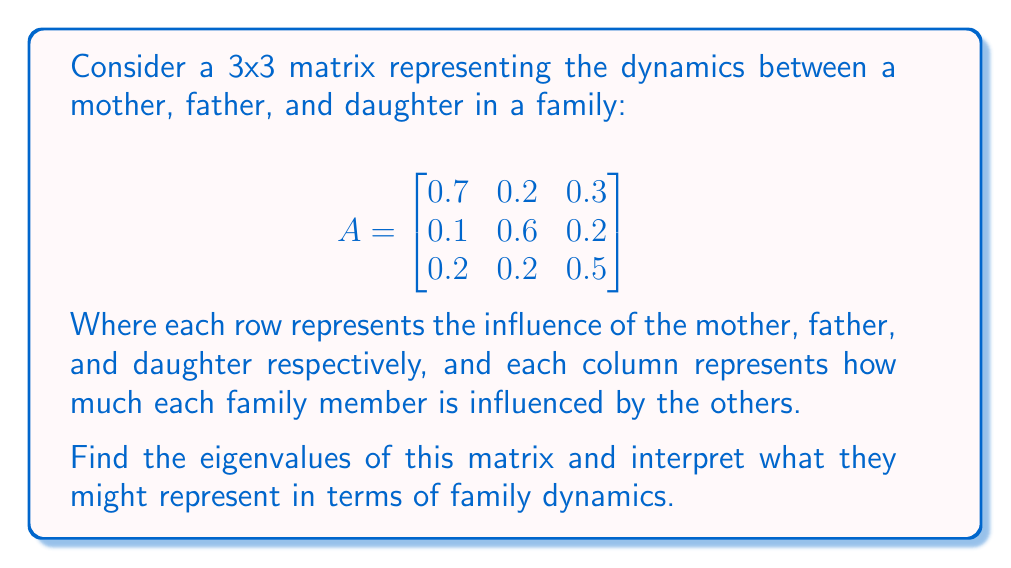Can you answer this question? To find the eigenvalues of matrix A, we need to solve the characteristic equation:

$$det(A - \lambda I) = 0$$

Where $\lambda$ represents the eigenvalues and $I$ is the 3x3 identity matrix.

Step 1: Set up the characteristic equation:

$$det\begin{pmatrix}
0.7-\lambda & 0.2 & 0.3 \\
0.1 & 0.6-\lambda & 0.2 \\
0.2 & 0.2 & 0.5-\lambda
\end{pmatrix} = 0$$

Step 2: Calculate the determinant:

$$(0.7-\lambda)[(0.6-\lambda)(0.5-\lambda) - 0.04] - 0.2[0.1(0.5-\lambda) - 0.06] + 0.3[0.02 - 0.1(0.6-\lambda)] = 0$$

Step 3: Expand and simplify:

$$-\lambda^3 + 1.8\lambda^2 - 0.83\lambda + 0.11 = 0$$

Step 4: Solve this cubic equation. The solutions are the eigenvalues:

$\lambda_1 \approx 1$
$\lambda_2 \approx 0.5$
$\lambda_3 \approx 0.3$

Interpretation:
The largest eigenvalue ($\lambda_1 \approx 1$) represents the dominant mode of interaction in the family. Being close to 1 suggests a stable family dynamic.

The second eigenvalue ($\lambda_2 \approx 0.5$) might represent a secondary mode of interaction, possibly between two family members.

The smallest eigenvalue ($\lambda_3 \approx 0.3$) could represent a weaker mode of interaction or an area where the family could improve their bond.

As a wise and empathetic teacher, you might suggest that the mother focus on strengthening the weaker interactions represented by the smaller eigenvalues to build a stronger overall family bond.
Answer: The eigenvalues of the matrix are approximately:
$\lambda_1 \approx 1$
$\lambda_2 \approx 0.5$
$\lambda_3 \approx 0.3$ 